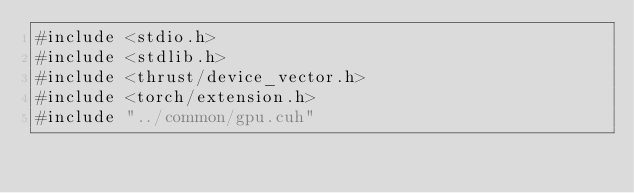Convert code to text. <code><loc_0><loc_0><loc_500><loc_500><_Cuda_>#include <stdio.h>
#include <stdlib.h>
#include <thrust/device_vector.h>
#include <torch/extension.h>
#include "../common/gpu.cuh"

</code> 